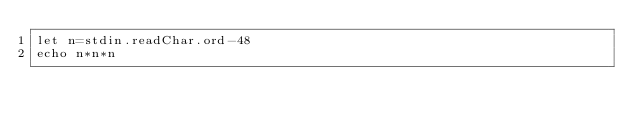Convert code to text. <code><loc_0><loc_0><loc_500><loc_500><_Nim_>let n=stdin.readChar.ord-48
echo n*n*n</code> 